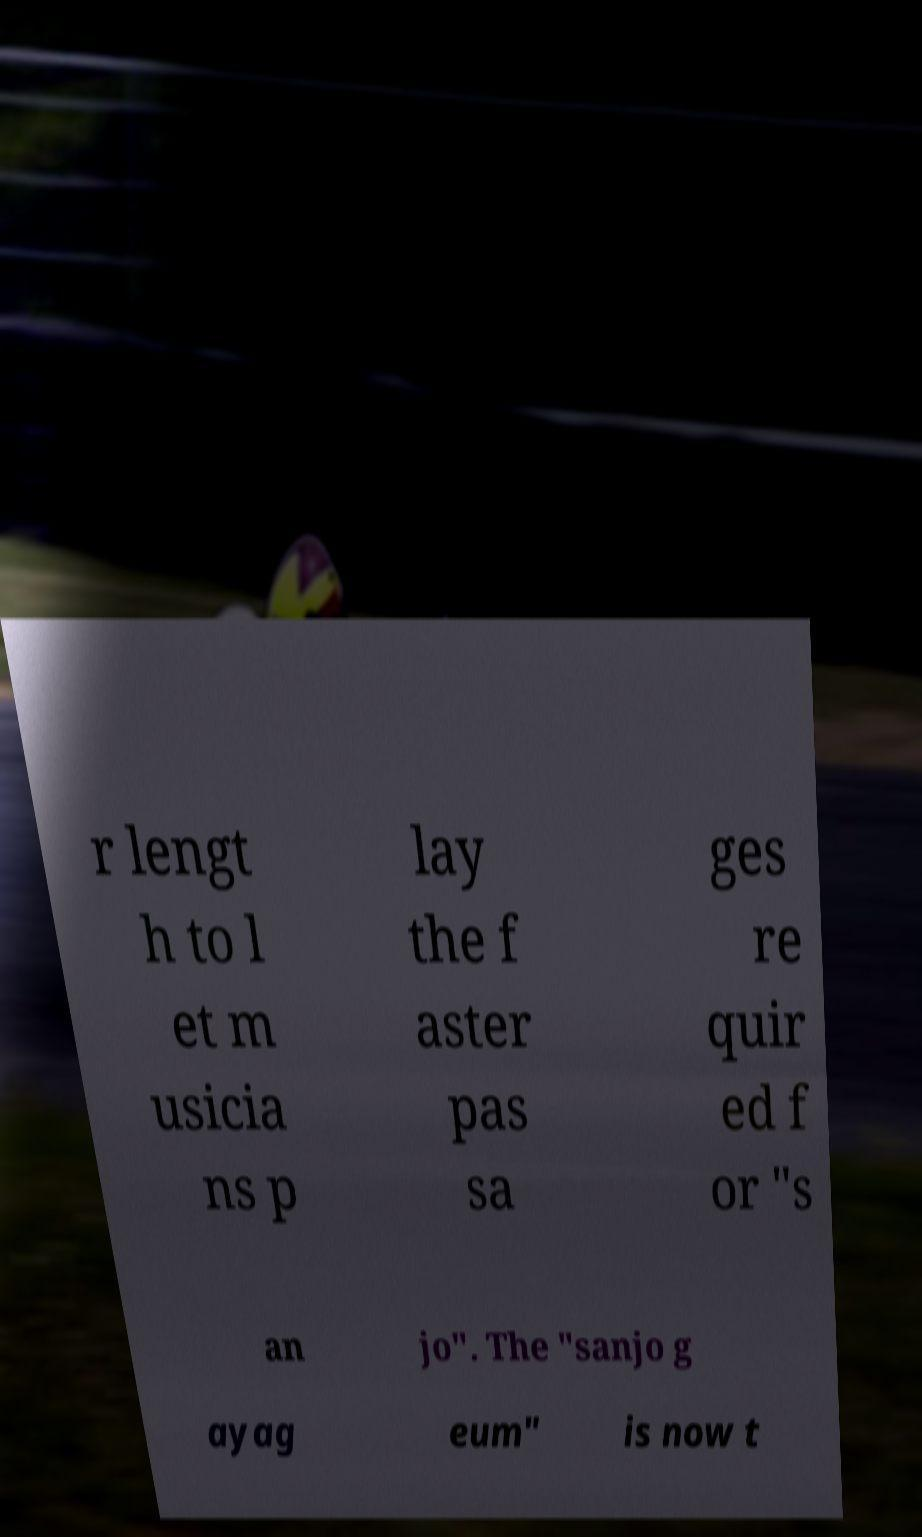Can you read and provide the text displayed in the image?This photo seems to have some interesting text. Can you extract and type it out for me? r lengt h to l et m usicia ns p lay the f aster pas sa ges re quir ed f or "s an jo". The "sanjo g ayag eum" is now t 